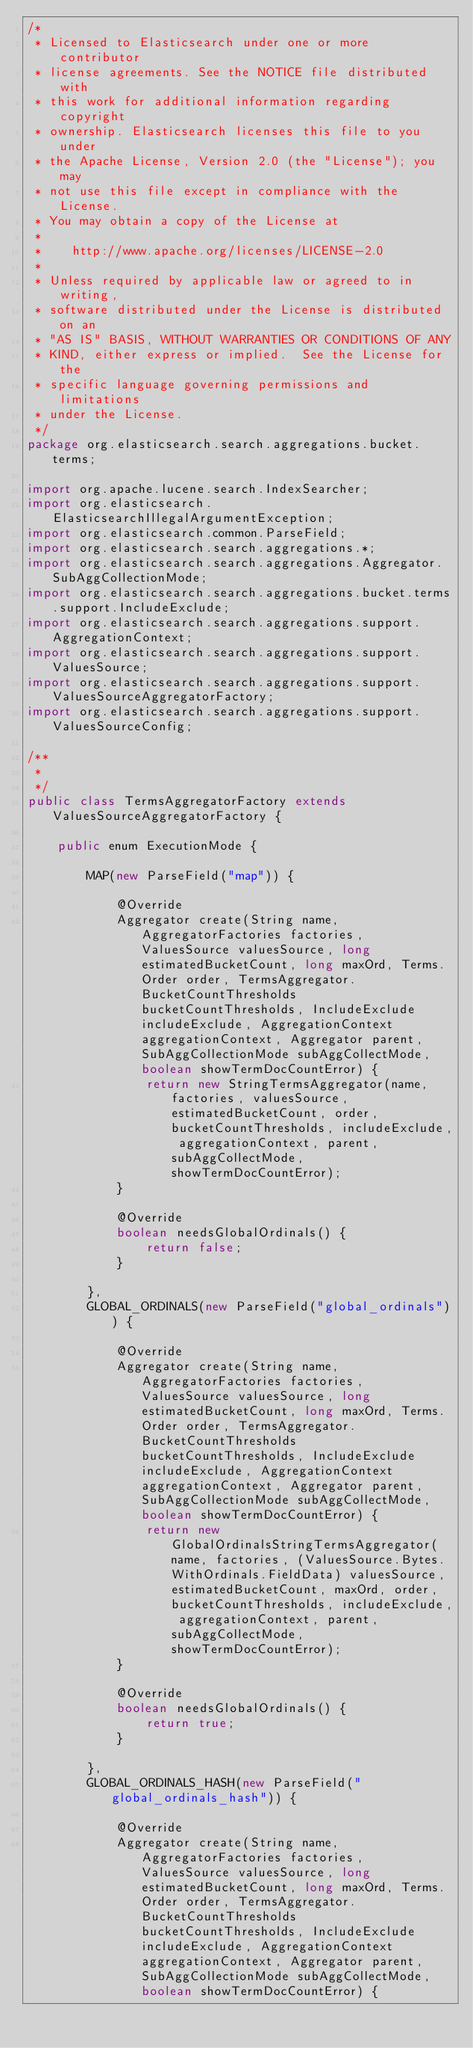<code> <loc_0><loc_0><loc_500><loc_500><_Java_>/*
 * Licensed to Elasticsearch under one or more contributor
 * license agreements. See the NOTICE file distributed with
 * this work for additional information regarding copyright
 * ownership. Elasticsearch licenses this file to you under
 * the Apache License, Version 2.0 (the "License"); you may
 * not use this file except in compliance with the License.
 * You may obtain a copy of the License at
 *
 *    http://www.apache.org/licenses/LICENSE-2.0
 *
 * Unless required by applicable law or agreed to in writing,
 * software distributed under the License is distributed on an
 * "AS IS" BASIS, WITHOUT WARRANTIES OR CONDITIONS OF ANY
 * KIND, either express or implied.  See the License for the
 * specific language governing permissions and limitations
 * under the License.
 */
package org.elasticsearch.search.aggregations.bucket.terms;

import org.apache.lucene.search.IndexSearcher;
import org.elasticsearch.ElasticsearchIllegalArgumentException;
import org.elasticsearch.common.ParseField;
import org.elasticsearch.search.aggregations.*;
import org.elasticsearch.search.aggregations.Aggregator.SubAggCollectionMode;
import org.elasticsearch.search.aggregations.bucket.terms.support.IncludeExclude;
import org.elasticsearch.search.aggregations.support.AggregationContext;
import org.elasticsearch.search.aggregations.support.ValuesSource;
import org.elasticsearch.search.aggregations.support.ValuesSourceAggregatorFactory;
import org.elasticsearch.search.aggregations.support.ValuesSourceConfig;

/**
 *
 */
public class TermsAggregatorFactory extends ValuesSourceAggregatorFactory {

    public enum ExecutionMode {

        MAP(new ParseField("map")) {

            @Override
            Aggregator create(String name, AggregatorFactories factories, ValuesSource valuesSource, long estimatedBucketCount, long maxOrd, Terms.Order order, TermsAggregator.BucketCountThresholds bucketCountThresholds, IncludeExclude includeExclude, AggregationContext aggregationContext, Aggregator parent, SubAggCollectionMode subAggCollectMode, boolean showTermDocCountError) {
                return new StringTermsAggregator(name, factories, valuesSource, estimatedBucketCount, order, bucketCountThresholds, includeExclude, aggregationContext, parent, subAggCollectMode, showTermDocCountError);
            }

            @Override
            boolean needsGlobalOrdinals() {
                return false;
            }

        },
        GLOBAL_ORDINALS(new ParseField("global_ordinals")) {

            @Override
            Aggregator create(String name, AggregatorFactories factories, ValuesSource valuesSource, long estimatedBucketCount, long maxOrd, Terms.Order order, TermsAggregator.BucketCountThresholds bucketCountThresholds, IncludeExclude includeExclude, AggregationContext aggregationContext, Aggregator parent, SubAggCollectionMode subAggCollectMode, boolean showTermDocCountError) {
                return new GlobalOrdinalsStringTermsAggregator(name, factories, (ValuesSource.Bytes.WithOrdinals.FieldData) valuesSource, estimatedBucketCount, maxOrd, order, bucketCountThresholds, includeExclude, aggregationContext, parent, subAggCollectMode, showTermDocCountError);
            }

            @Override
            boolean needsGlobalOrdinals() {
                return true;
            }

        },
        GLOBAL_ORDINALS_HASH(new ParseField("global_ordinals_hash")) {

            @Override
            Aggregator create(String name, AggregatorFactories factories, ValuesSource valuesSource, long estimatedBucketCount, long maxOrd, Terms.Order order, TermsAggregator.BucketCountThresholds bucketCountThresholds, IncludeExclude includeExclude, AggregationContext aggregationContext, Aggregator parent, SubAggCollectionMode subAggCollectMode, boolean showTermDocCountError) {</code> 